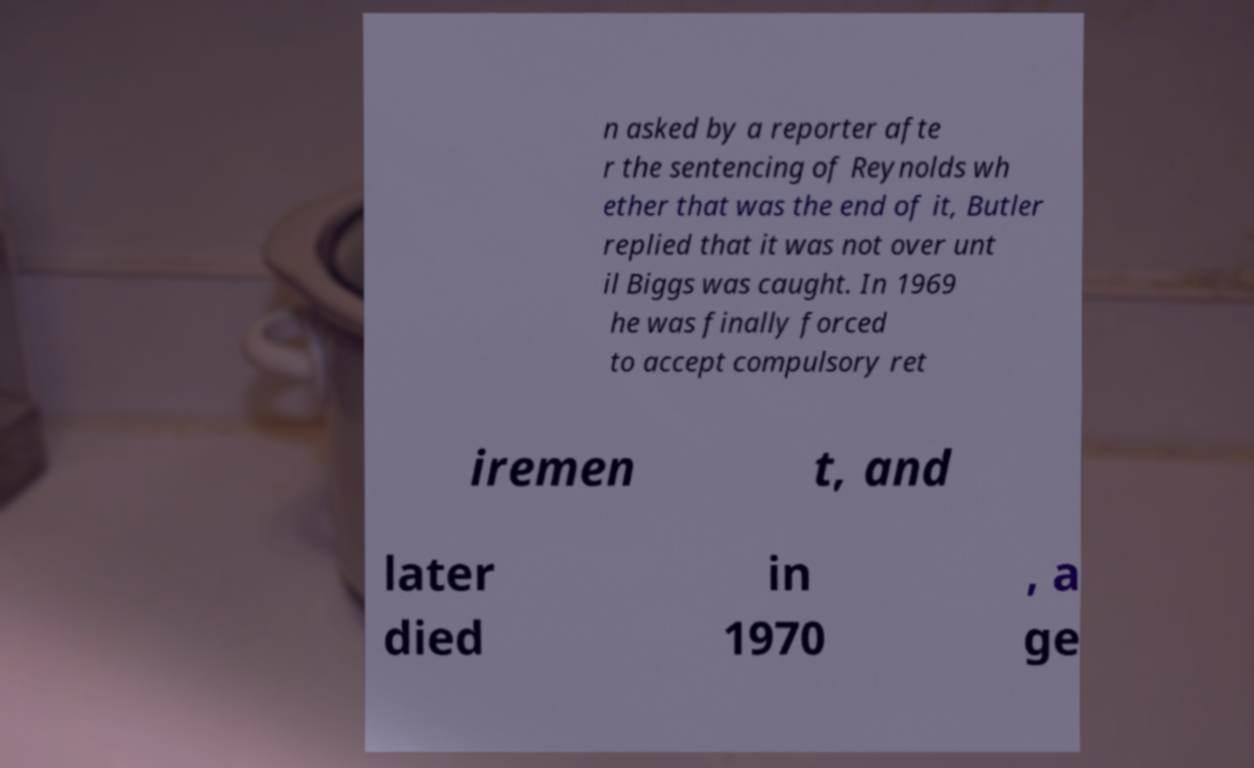Could you extract and type out the text from this image? n asked by a reporter afte r the sentencing of Reynolds wh ether that was the end of it, Butler replied that it was not over unt il Biggs was caught. In 1969 he was finally forced to accept compulsory ret iremen t, and later died in 1970 , a ge 